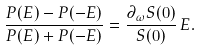Convert formula to latex. <formula><loc_0><loc_0><loc_500><loc_500>\frac { P ( E ) - P ( - E ) } { P ( E ) + P ( - E ) } = \frac { \partial _ { \omega } S ( 0 ) } { S ( 0 ) } \, E .</formula> 